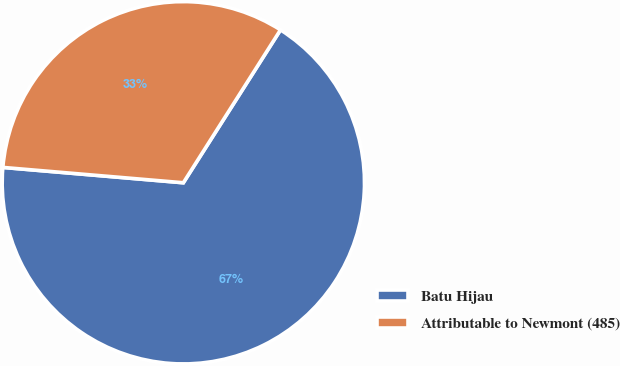Convert chart to OTSL. <chart><loc_0><loc_0><loc_500><loc_500><pie_chart><fcel>Batu Hijau<fcel>Attributable to Newmont (485)<nl><fcel>67.34%<fcel>32.66%<nl></chart> 